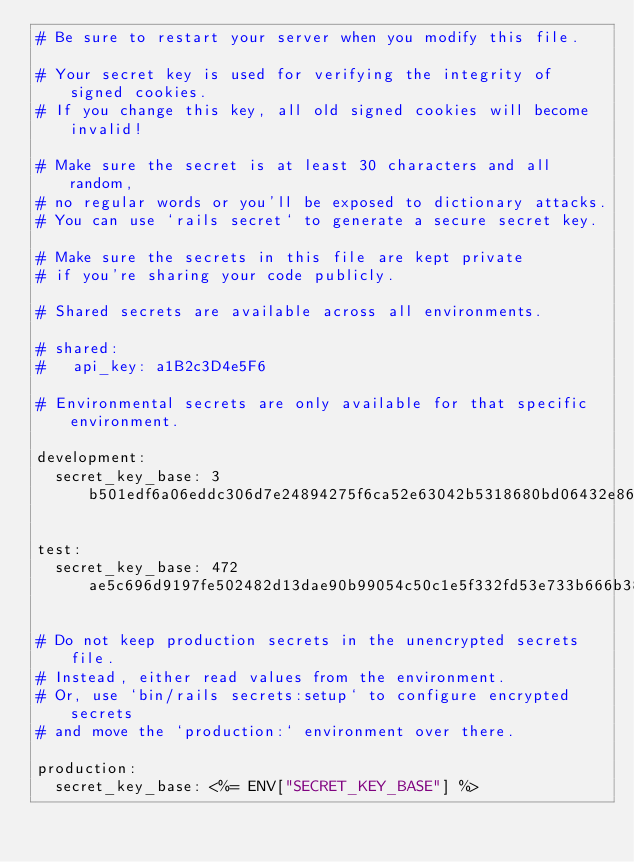<code> <loc_0><loc_0><loc_500><loc_500><_YAML_># Be sure to restart your server when you modify this file.

# Your secret key is used for verifying the integrity of signed cookies.
# If you change this key, all old signed cookies will become invalid!

# Make sure the secret is at least 30 characters and all random,
# no regular words or you'll be exposed to dictionary attacks.
# You can use `rails secret` to generate a secure secret key.

# Make sure the secrets in this file are kept private
# if you're sharing your code publicly.

# Shared secrets are available across all environments.

# shared:
#   api_key: a1B2c3D4e5F6

# Environmental secrets are only available for that specific environment.

development:
  secret_key_base: 3b501edf6a06eddc306d7e24894275f6ca52e63042b5318680bd06432e86620a315dc0a46c451b2f62bf54740b3821928665af2d484caded71fb009eb2f6c2ba

test:
  secret_key_base: 472ae5c696d9197fe502482d13dae90b99054c50c1e5f332fd53e733b666b38376df307ce71c029fed904d49cde2940d39400bf857acbe107f08081773737514

# Do not keep production secrets in the unencrypted secrets file.
# Instead, either read values from the environment.
# Or, use `bin/rails secrets:setup` to configure encrypted secrets
# and move the `production:` environment over there.

production:
  secret_key_base: <%= ENV["SECRET_KEY_BASE"] %>
</code> 